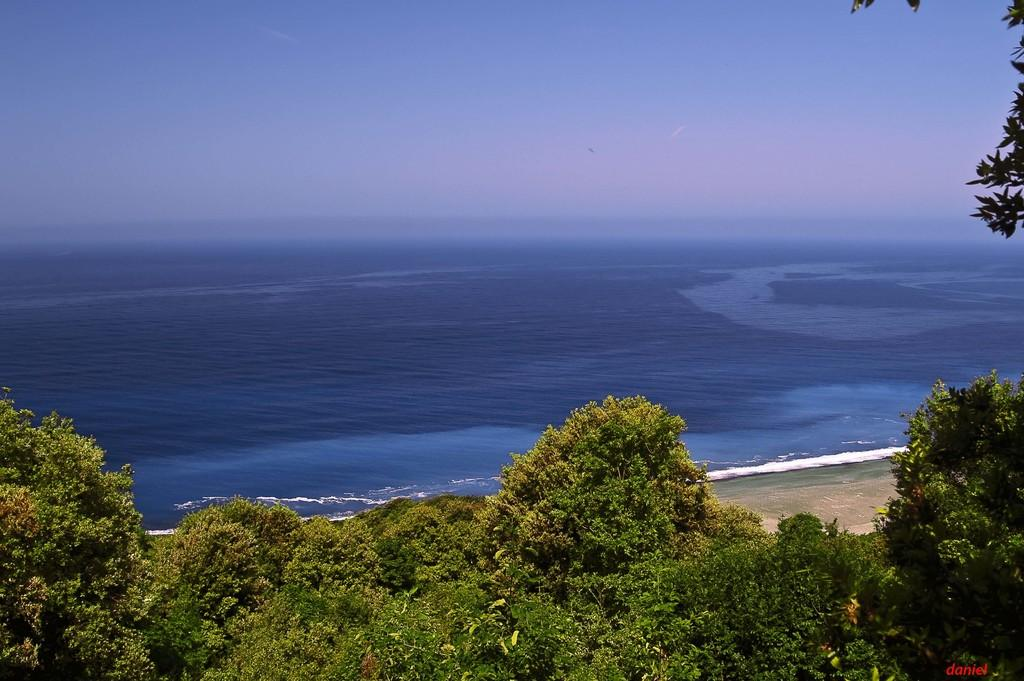What type of vegetation can be seen in the image? There are trees in the image. What can be seen in the background of the image? There is water and the sky visible in the background of the image. Is there any text present in the image? Yes, there is some text in the bottom right corner of the image. What type of lamp is hanging from the roof in the image? There is no lamp or roof present in the image; it features trees, water, and the sky in the background. 